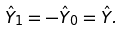<formula> <loc_0><loc_0><loc_500><loc_500>\hat { Y } _ { 1 } = - \hat { Y } _ { 0 } = \hat { Y } .</formula> 